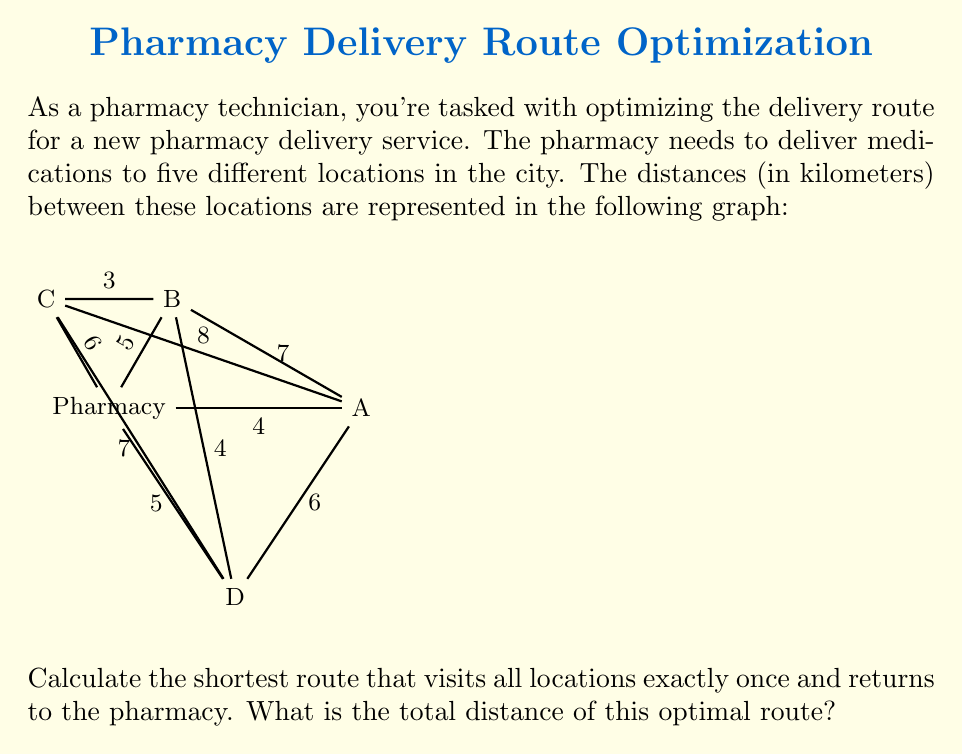Give your solution to this math problem. To solve this problem, we need to find the shortest Hamiltonian cycle in the given graph, which is known as the Traveling Salesman Problem (TSP). For a small graph like this, we can use the brute-force method to find the optimal solution.

Step 1: List all possible routes.
There are $(5-1)! = 24$ possible routes, as we start and end at the pharmacy.

Step 2: Calculate the distance for each route.
Let's represent the pharmacy as P and the other locations as A, B, C, and D.

For example:
P-A-B-C-D-P = 4 + 7 + 3 + 7 + 6 = 27 km
P-A-B-D-C-P = 4 + 8 + 7 + 3 + 5 = 27 km
...

Step 3: Compare all routes and find the shortest one.
After calculating all routes, we find that the shortest route is:

P-A-B-C-D-P = 4 + 7 + 3 + 7 + 6 = 27 km

This route visits all locations once and returns to the pharmacy with the minimum total distance.

Step 4: Verify that no shorter route exists.
We can confirm that any other permutation of the locations results in a longer total distance.

Therefore, the optimal route for the pharmacy delivery service is Pharmacy - A - B - C - D - Pharmacy, with a total distance of 27 km.
Answer: 27 km 